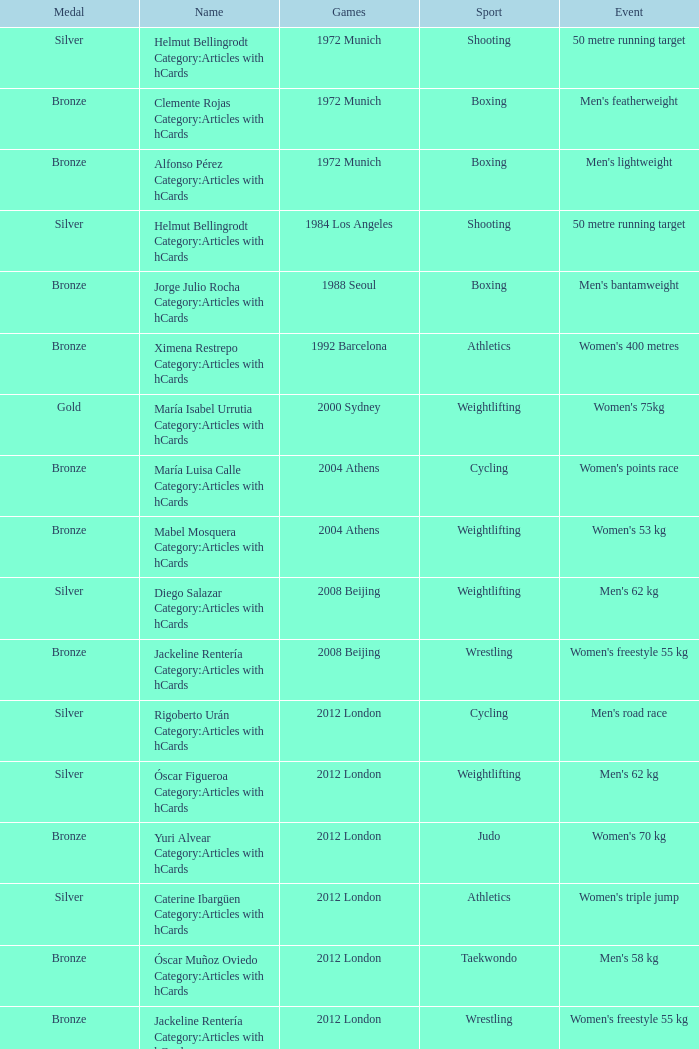Which sport resulted in a gold medal in the 2000 Sydney games? Weightlifting. Would you mind parsing the complete table? {'header': ['Medal', 'Name', 'Games', 'Sport', 'Event'], 'rows': [['Silver', 'Helmut Bellingrodt Category:Articles with hCards', '1972 Munich', 'Shooting', '50 metre running target'], ['Bronze', 'Clemente Rojas Category:Articles with hCards', '1972 Munich', 'Boxing', "Men's featherweight"], ['Bronze', 'Alfonso Pérez Category:Articles with hCards', '1972 Munich', 'Boxing', "Men's lightweight"], ['Silver', 'Helmut Bellingrodt Category:Articles with hCards', '1984 Los Angeles', 'Shooting', '50 metre running target'], ['Bronze', 'Jorge Julio Rocha Category:Articles with hCards', '1988 Seoul', 'Boxing', "Men's bantamweight"], ['Bronze', 'Ximena Restrepo Category:Articles with hCards', '1992 Barcelona', 'Athletics', "Women's 400 metres"], ['Gold', 'María Isabel Urrutia Category:Articles with hCards', '2000 Sydney', 'Weightlifting', "Women's 75kg"], ['Bronze', 'María Luisa Calle Category:Articles with hCards', '2004 Athens', 'Cycling', "Women's points race"], ['Bronze', 'Mabel Mosquera Category:Articles with hCards', '2004 Athens', 'Weightlifting', "Women's 53 kg"], ['Silver', 'Diego Salazar Category:Articles with hCards', '2008 Beijing', 'Weightlifting', "Men's 62 kg"], ['Bronze', 'Jackeline Rentería Category:Articles with hCards', '2008 Beijing', 'Wrestling', "Women's freestyle 55 kg"], ['Silver', 'Rigoberto Urán Category:Articles with hCards', '2012 London', 'Cycling', "Men's road race"], ['Silver', 'Óscar Figueroa Category:Articles with hCards', '2012 London', 'Weightlifting', "Men's 62 kg"], ['Bronze', 'Yuri Alvear Category:Articles with hCards', '2012 London', 'Judo', "Women's 70 kg"], ['Silver', 'Caterine Ibargüen Category:Articles with hCards', '2012 London', 'Athletics', "Women's triple jump"], ['Bronze', 'Óscar Muñoz Oviedo Category:Articles with hCards', '2012 London', 'Taekwondo', "Men's 58 kg"], ['Bronze', 'Jackeline Rentería Category:Articles with hCards', '2012 London', 'Wrestling', "Women's freestyle 55 kg"], ['Gold', 'Mariana Pajón Category:Articles with hCards', '2012 London', 'Cycling', "Women's BMX"], ['Bronze', 'Carlos Oquendo Category:Articles with hCards', '2012 London', 'Cycling', "Men's BMX"]]} 